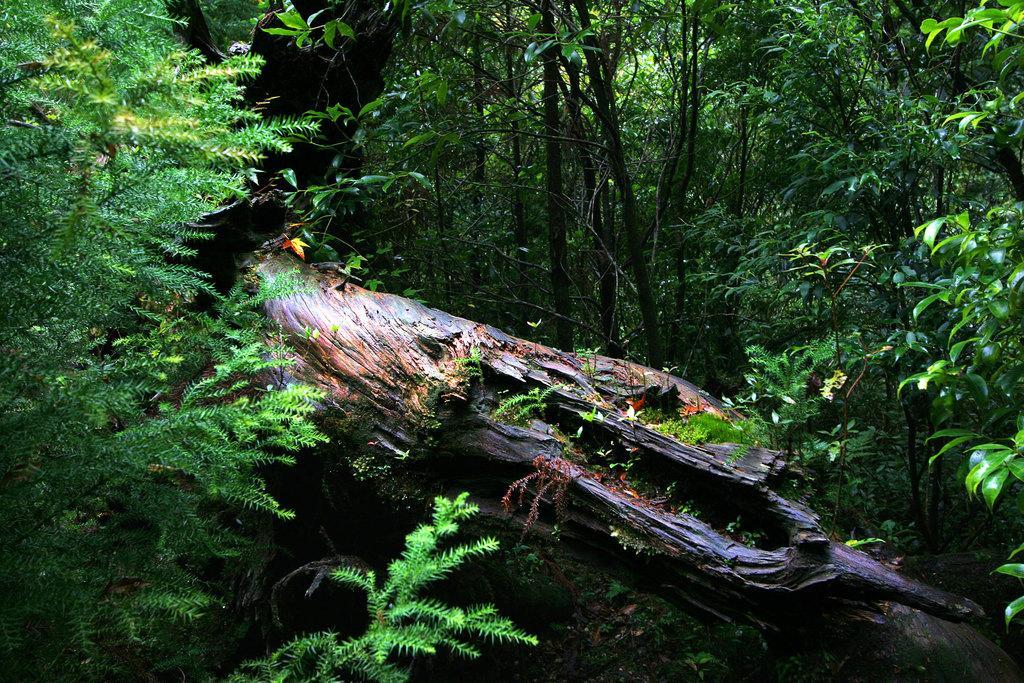In one or two sentences, can you explain what this image depicts? In the image we can see there are lot of trees in the image and in between there is a tree log. 